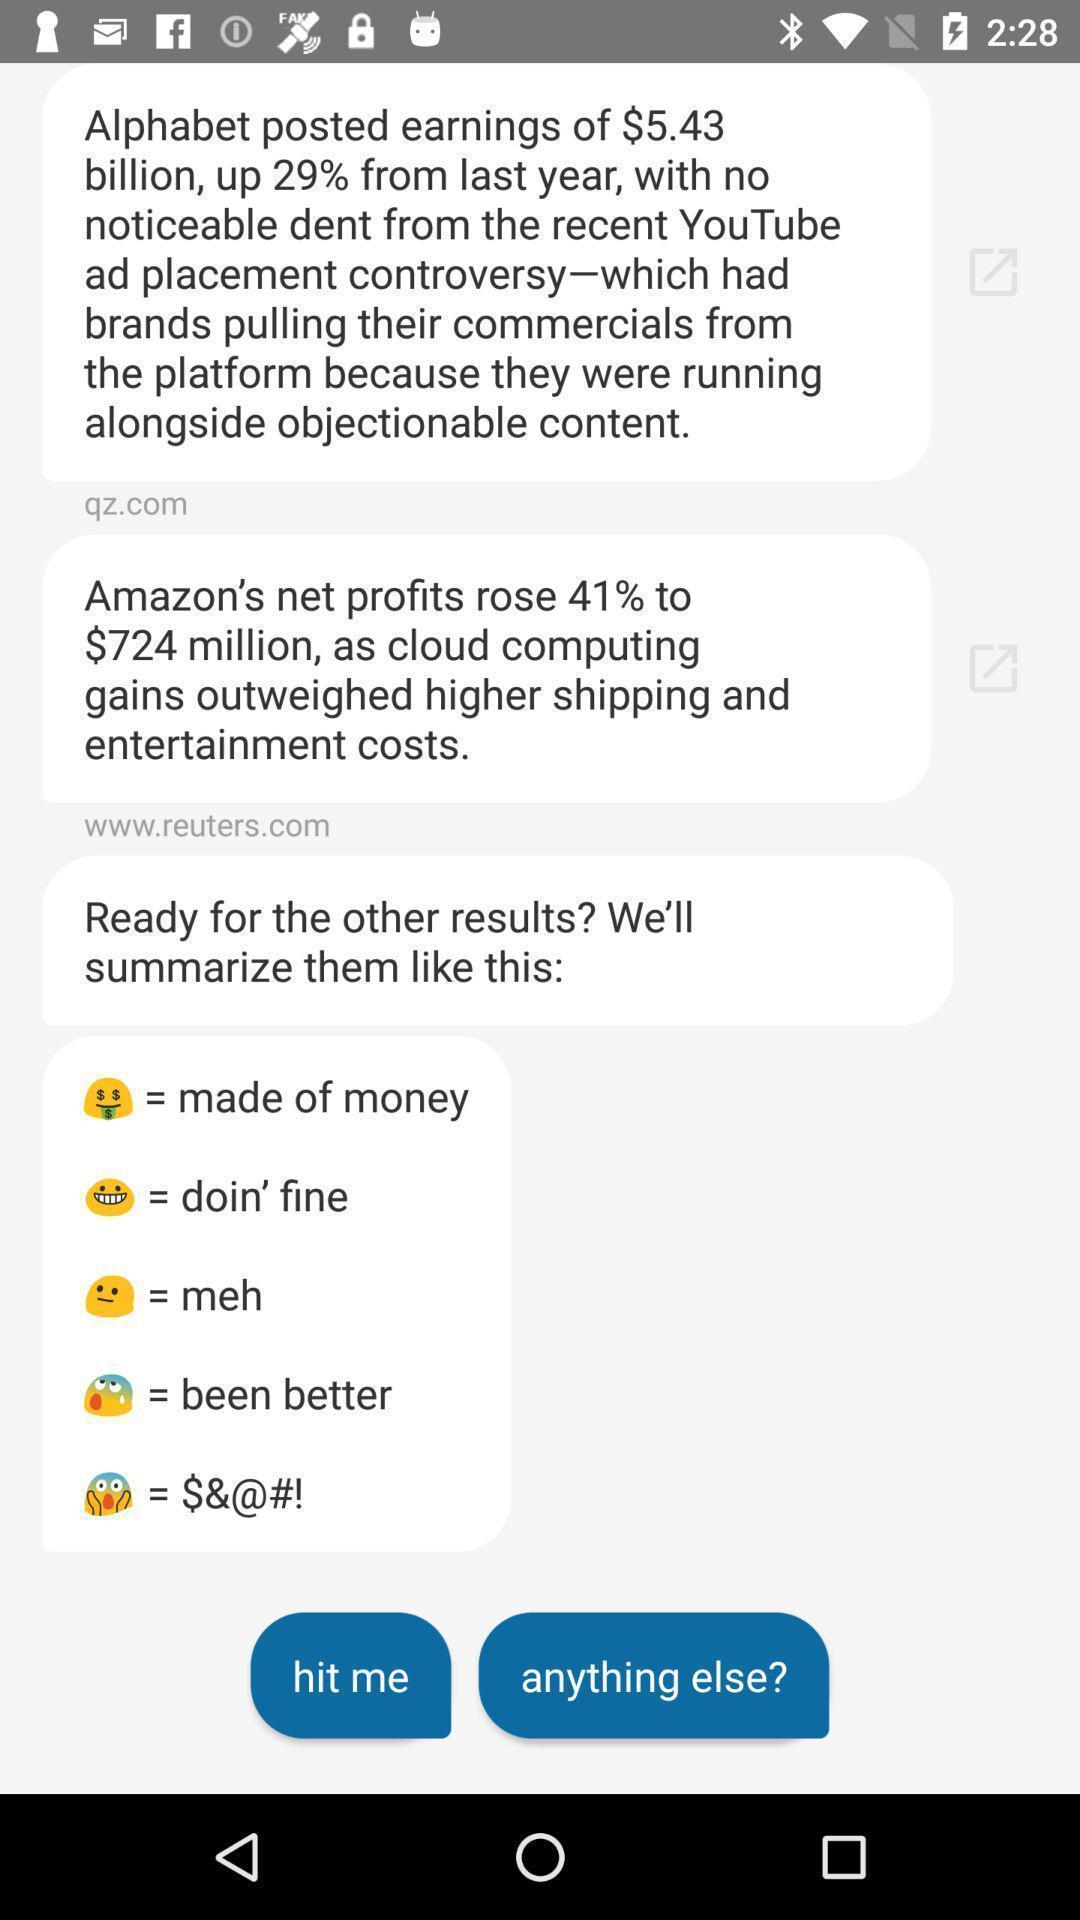Tell me what you see in this picture. Page displaying list of text messages. 